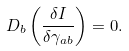<formula> <loc_0><loc_0><loc_500><loc_500>D _ { b } \left ( \frac { \delta I } { \delta \gamma _ { a b } } \right ) = 0 .</formula> 